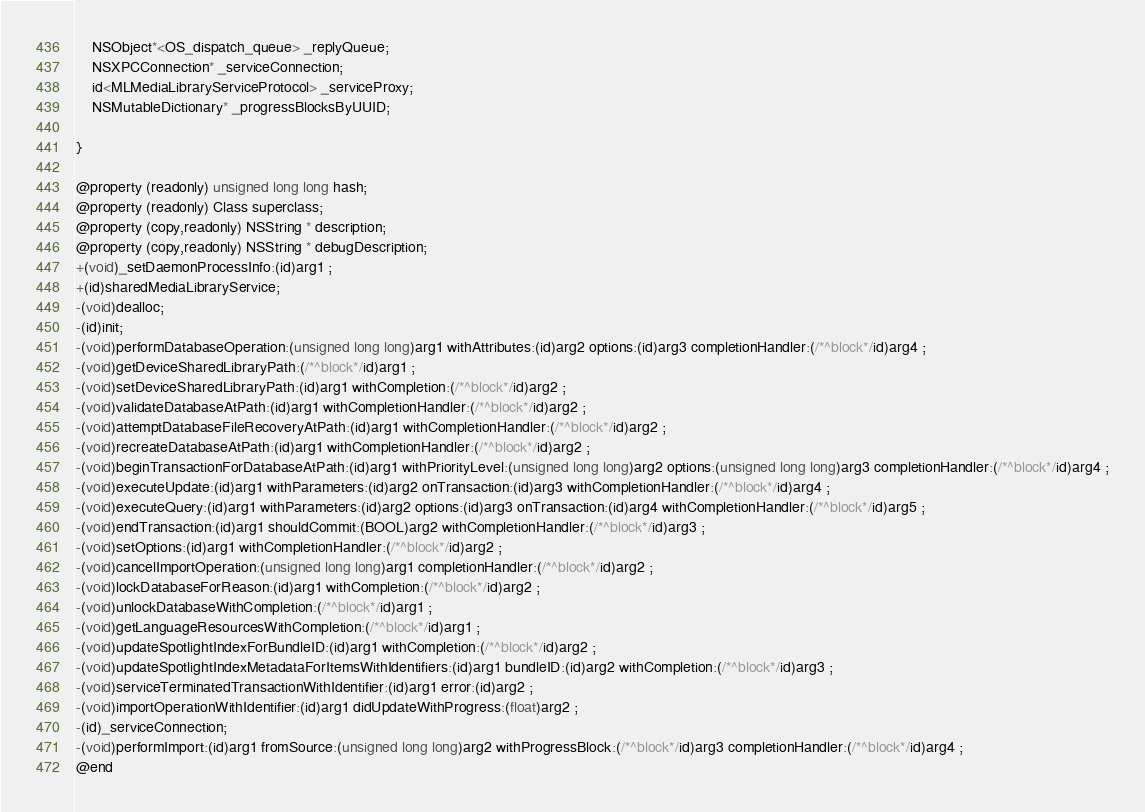Convert code to text. <code><loc_0><loc_0><loc_500><loc_500><_C_>	NSObject*<OS_dispatch_queue> _replyQueue;
	NSXPCConnection* _serviceConnection;
	id<MLMediaLibraryServiceProtocol> _serviceProxy;
	NSMutableDictionary* _progressBlocksByUUID;

}

@property (readonly) unsigned long long hash; 
@property (readonly) Class superclass; 
@property (copy,readonly) NSString * description; 
@property (copy,readonly) NSString * debugDescription; 
+(void)_setDaemonProcessInfo:(id)arg1 ;
+(id)sharedMediaLibraryService;
-(void)dealloc;
-(id)init;
-(void)performDatabaseOperation:(unsigned long long)arg1 withAttributes:(id)arg2 options:(id)arg3 completionHandler:(/*^block*/id)arg4 ;
-(void)getDeviceSharedLibraryPath:(/*^block*/id)arg1 ;
-(void)setDeviceSharedLibraryPath:(id)arg1 withCompletion:(/*^block*/id)arg2 ;
-(void)validateDatabaseAtPath:(id)arg1 withCompletionHandler:(/*^block*/id)arg2 ;
-(void)attemptDatabaseFileRecoveryAtPath:(id)arg1 withCompletionHandler:(/*^block*/id)arg2 ;
-(void)recreateDatabaseAtPath:(id)arg1 withCompletionHandler:(/*^block*/id)arg2 ;
-(void)beginTransactionForDatabaseAtPath:(id)arg1 withPriorityLevel:(unsigned long long)arg2 options:(unsigned long long)arg3 completionHandler:(/*^block*/id)arg4 ;
-(void)executeUpdate:(id)arg1 withParameters:(id)arg2 onTransaction:(id)arg3 withCompletionHandler:(/*^block*/id)arg4 ;
-(void)executeQuery:(id)arg1 withParameters:(id)arg2 options:(id)arg3 onTransaction:(id)arg4 withCompletionHandler:(/*^block*/id)arg5 ;
-(void)endTransaction:(id)arg1 shouldCommit:(BOOL)arg2 withCompletionHandler:(/*^block*/id)arg3 ;
-(void)setOptions:(id)arg1 withCompletionHandler:(/*^block*/id)arg2 ;
-(void)cancelImportOperation:(unsigned long long)arg1 completionHandler:(/*^block*/id)arg2 ;
-(void)lockDatabaseForReason:(id)arg1 withCompletion:(/*^block*/id)arg2 ;
-(void)unlockDatabaseWithCompletion:(/*^block*/id)arg1 ;
-(void)getLanguageResourcesWithCompletion:(/*^block*/id)arg1 ;
-(void)updateSpotlightIndexForBundleID:(id)arg1 withCompletion:(/*^block*/id)arg2 ;
-(void)updateSpotlightIndexMetadataForItemsWithIdentifiers:(id)arg1 bundleID:(id)arg2 withCompletion:(/*^block*/id)arg3 ;
-(void)serviceTerminatedTransactionWithIdentifier:(id)arg1 error:(id)arg2 ;
-(void)importOperationWithIdentifier:(id)arg1 didUpdateWithProgress:(float)arg2 ;
-(id)_serviceConnection;
-(void)performImport:(id)arg1 fromSource:(unsigned long long)arg2 withProgressBlock:(/*^block*/id)arg3 completionHandler:(/*^block*/id)arg4 ;
@end

</code> 